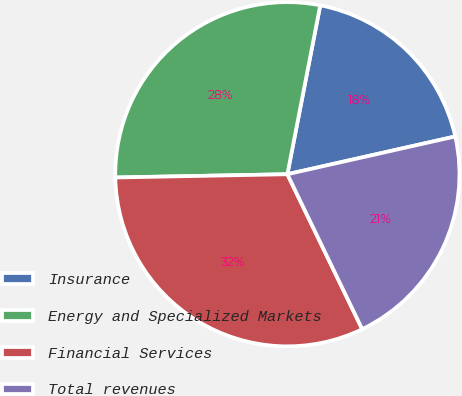<chart> <loc_0><loc_0><loc_500><loc_500><pie_chart><fcel>Insurance<fcel>Energy and Specialized Markets<fcel>Financial Services<fcel>Total revenues<nl><fcel>18.42%<fcel>28.36%<fcel>31.86%<fcel>21.36%<nl></chart> 